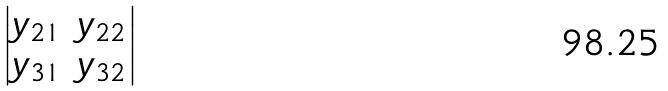Convert formula to latex. <formula><loc_0><loc_0><loc_500><loc_500>\begin{vmatrix} y _ { 2 1 } & y _ { 2 2 } \\ y _ { 3 1 } & y _ { 3 2 } \end{vmatrix}</formula> 